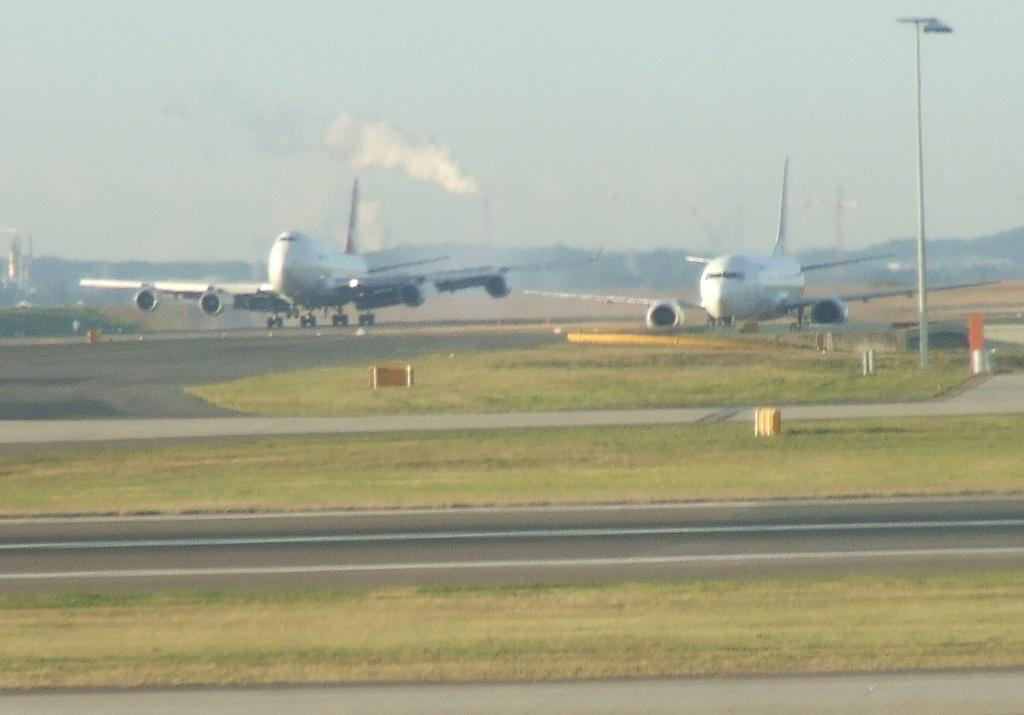What type of pathway is present in the image? There is a road in the image. What vehicles can be seen in the image? There are planes in the image. What type of vegetation is visible in the image? There is grass visible in the image. What structure can be seen in the image? There is a pole in the image. What is visible in the background of the image? The sky is visible in the background of the image. What is the name of the list that the planes are following in the image? There is no list present in the image, and the planes are not following any specific list. How quiet is the environment in the image? The level of noise or quietness cannot be determined from the image alone, as there are no audible cues provided. 